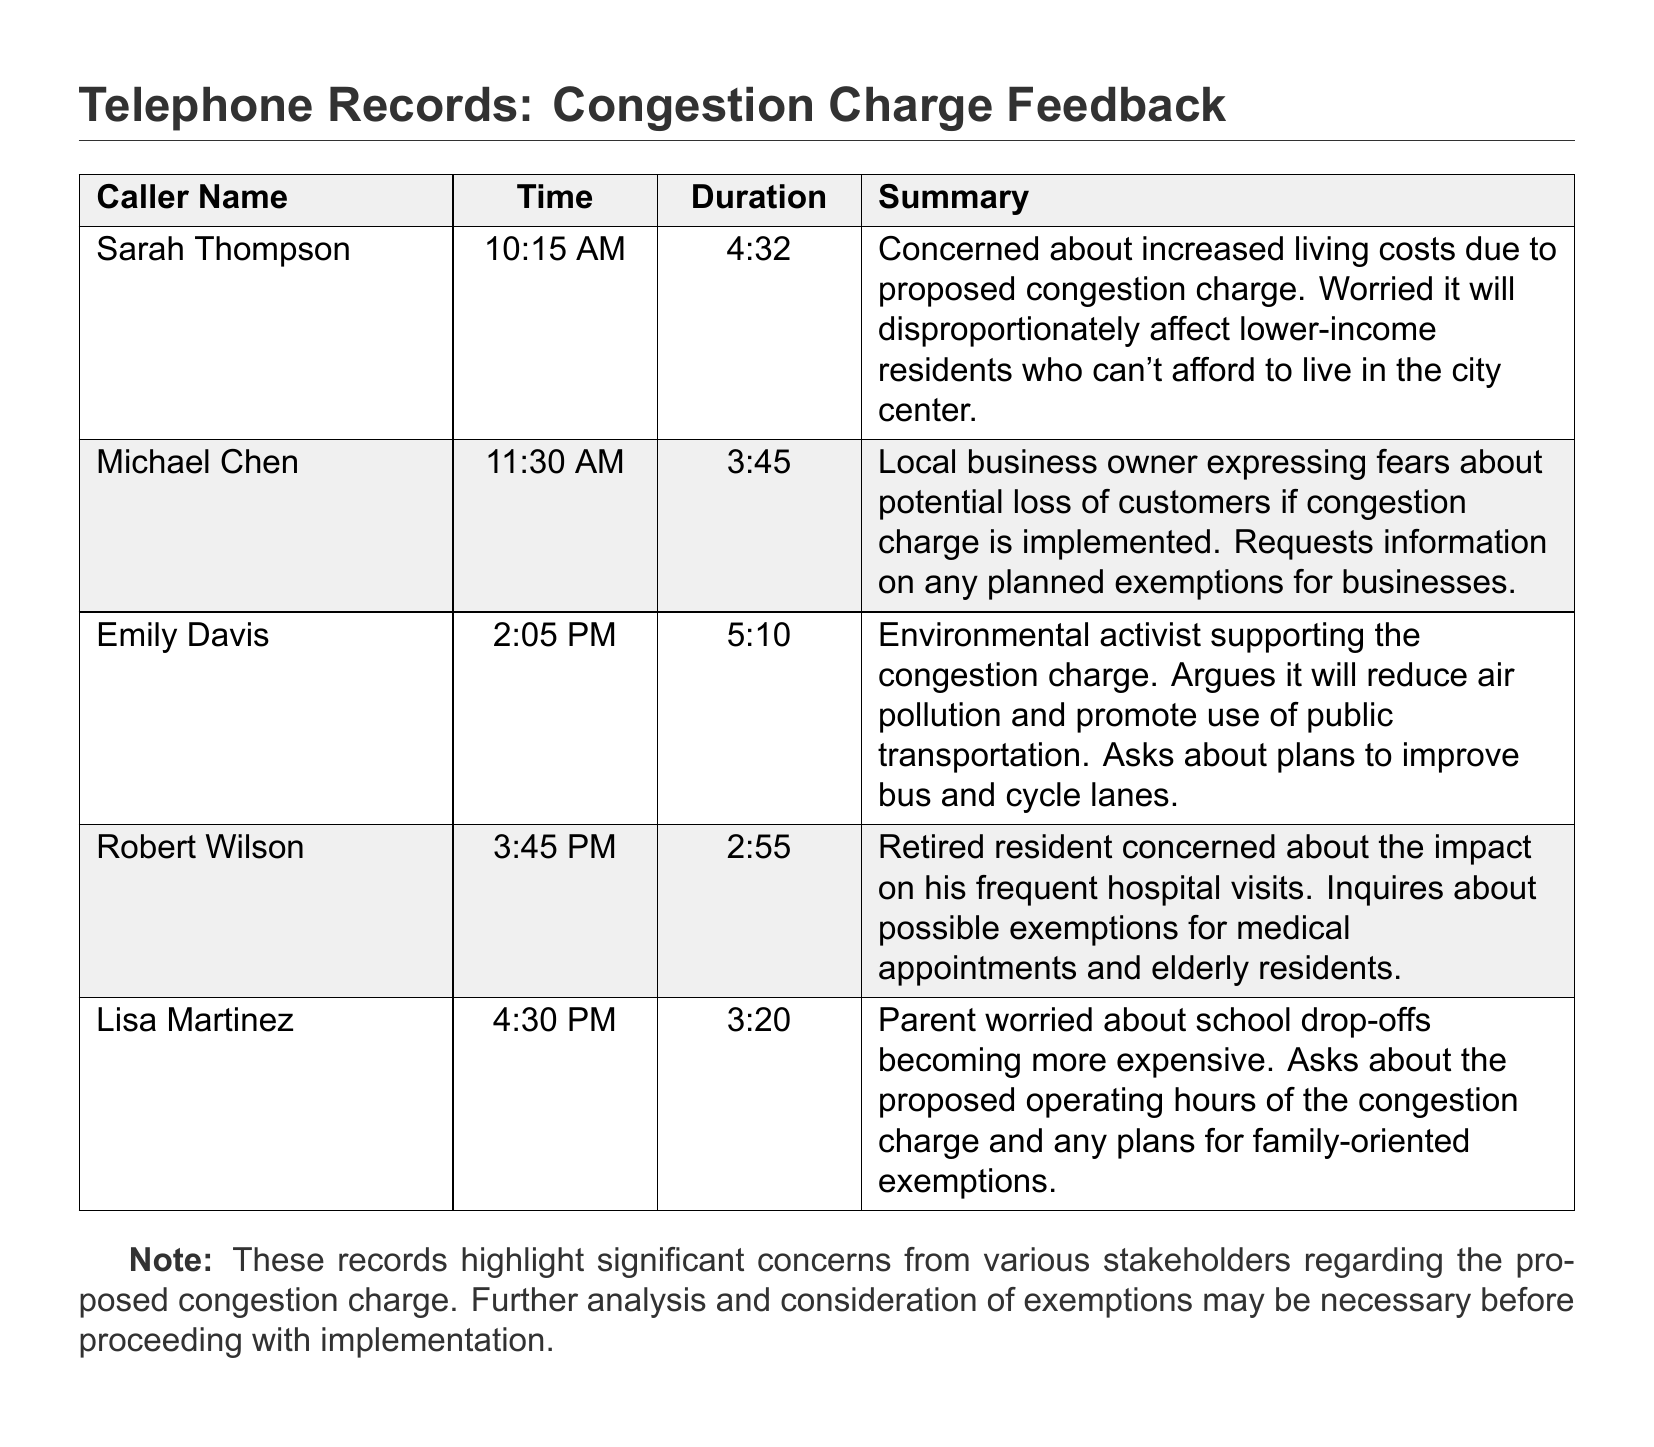What time did Sarah Thompson call? Sarah Thompson's call time can be found in the document, listed under "Time."
Answer: 10:15 AM How long did Emily Davis spend on the call? The duration of Emily Davis's call is specified next to her name in the document.
Answer: 5:10 What is Michael Chen's concern about the congestion charge? Michael Chen's summary indicates his main worry about the congestion charge's impact on his business.
Answer: Potential loss of customers What support did Emily Davis express regarding the congestion charge? Emily Davis's statement shows her viewpoint on the environmental benefits of the congestion charge.
Answer: Supports reduction of air pollution What did Robert Wilson inquire about? Robert Wilson's call summary details the specific exemption he wants information about.
Answer: Medical appointments and elderly residents How many callers mentioned concerns related to their personal finances? Personal finance-related concerns are noted in the summaries of certain callers.
Answer: Two What type of record is this document? The nature of the document is identified in its title, explaining its content.
Answer: Telephone records What time did Lisa Martinez call? The specific call time for Lisa Martinez is listed in the document.
Answer: 4:30 PM What was a common theme among the callers' feedback? A review of the callers' summaries reveals overlapping issues they addressed regarding the proposed charge.
Answer: Impact on residents and businesses 